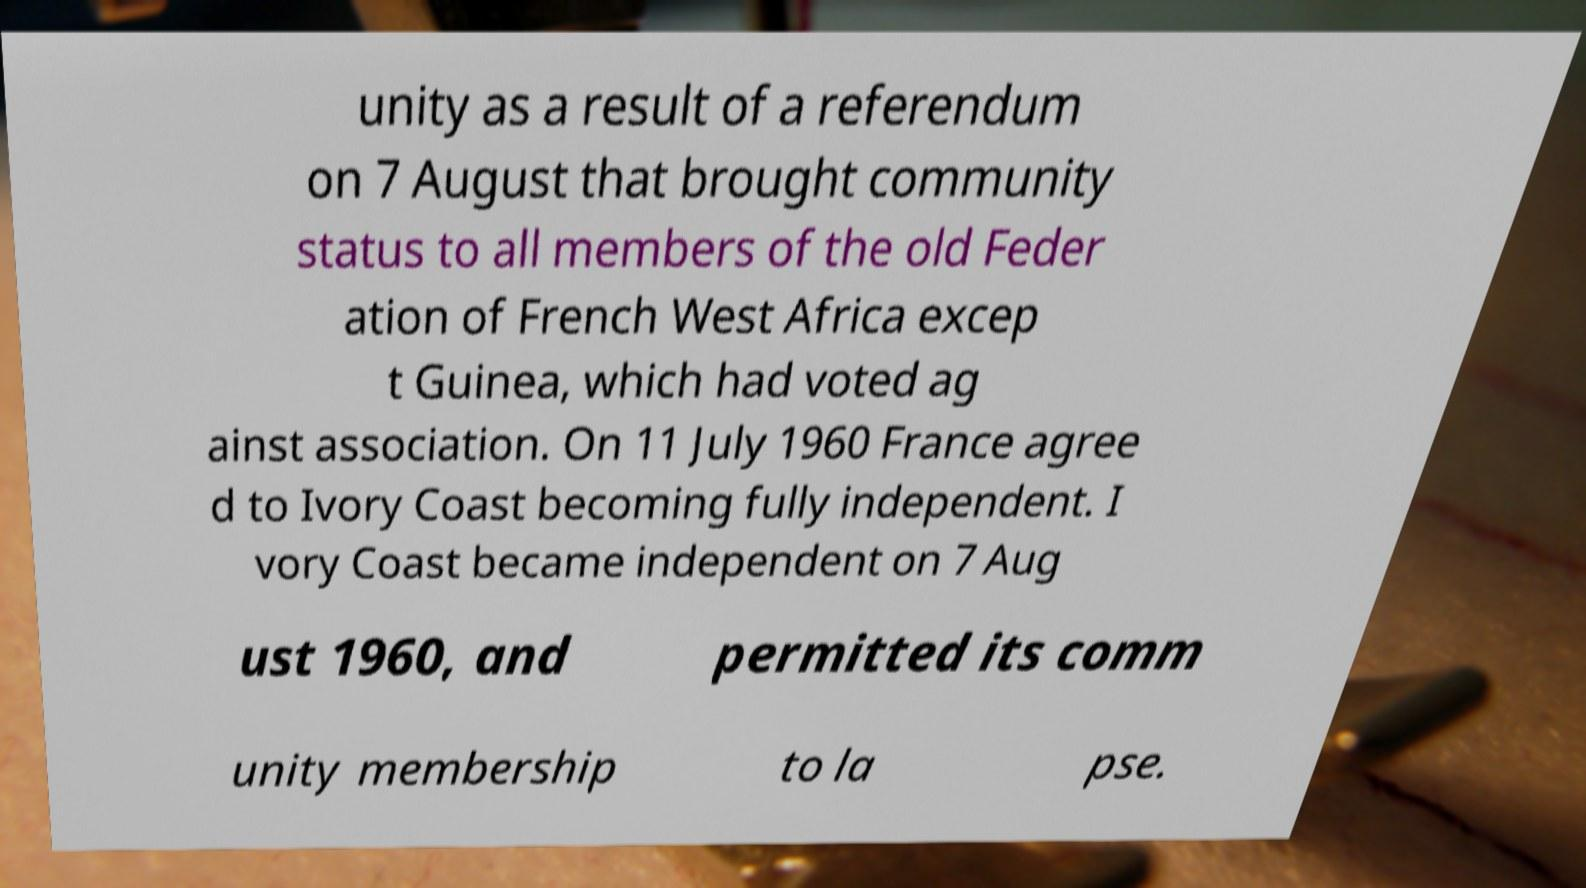Please read and relay the text visible in this image. What does it say? unity as a result of a referendum on 7 August that brought community status to all members of the old Feder ation of French West Africa excep t Guinea, which had voted ag ainst association. On 11 July 1960 France agree d to Ivory Coast becoming fully independent. I vory Coast became independent on 7 Aug ust 1960, and permitted its comm unity membership to la pse. 